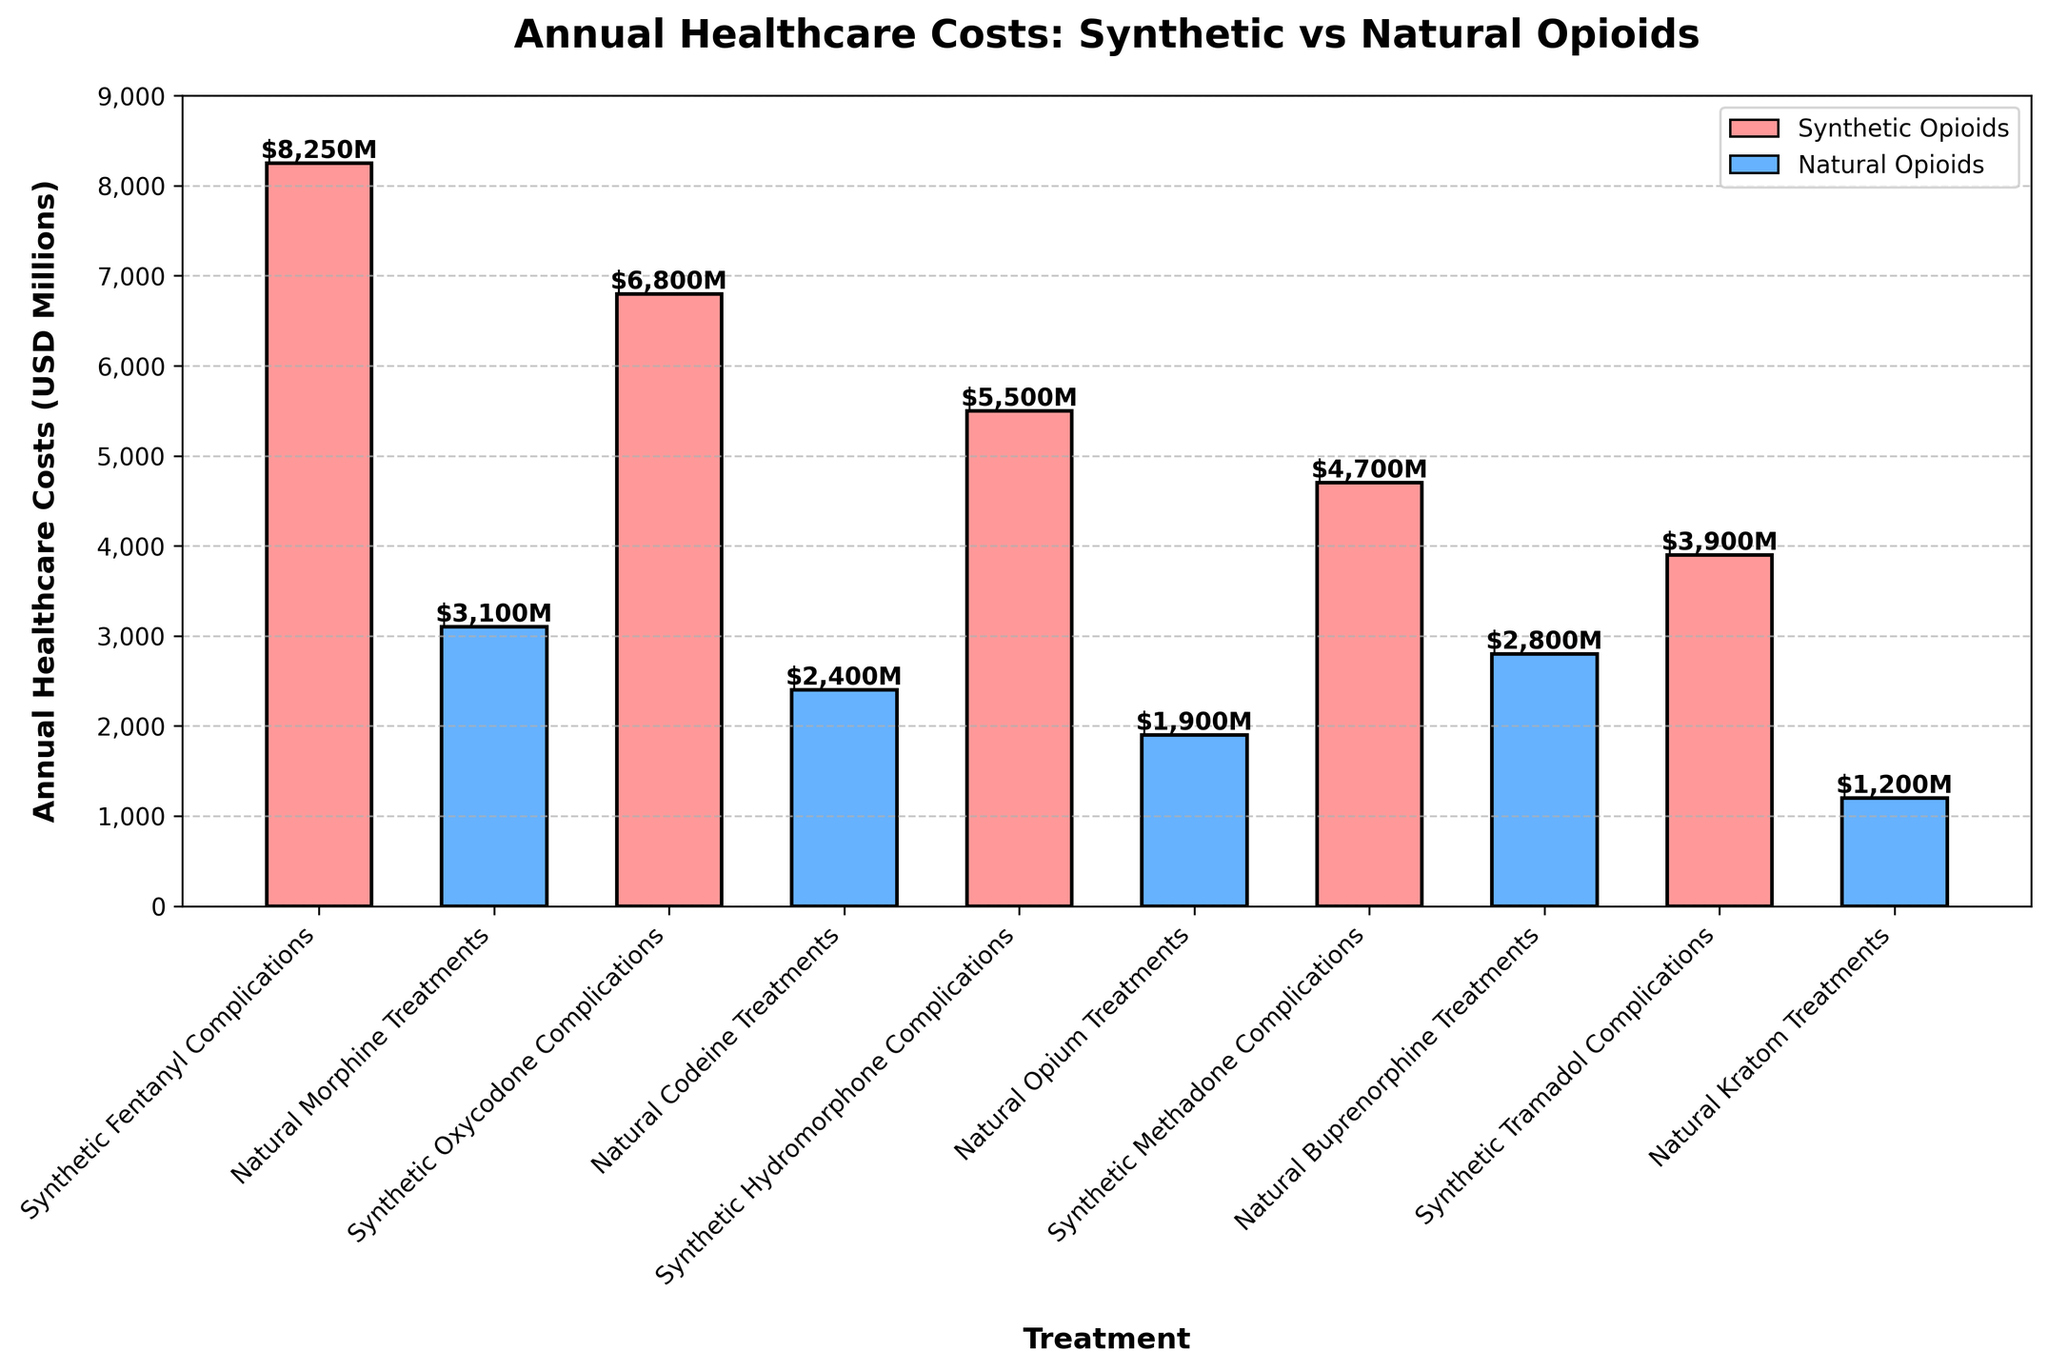Which treatment has the highest annual healthcare cost? The treatment with the highest annual healthcare cost will be the tallest bar in the bar chart. This bar represents synthetic fentanyl complications with a cost of $8,250 million.
Answer: Synthetic fentanyl complications Which treatment has the lowest annual healthcare cost? The treatment with the lowest annual healthcare cost will be the shortest bar in the bar chart. This bar represents natural kratom treatments with a cost of $1,200 million.
Answer: Natural kratom treatments What is the total annual healthcare cost for all synthetic opioid-related complications? Sum the annual healthcare costs of all synthetic opioid-related complications: $8,250M (fentanyl) + $6,800M (oxycodone) + $5,500M (hydromorphone) + $4,700M (methadone) + $3,900M (tramadol) = $29,150 million.
Answer: $29,150 million What is the average annual healthcare cost for natural opioid treatments? Calculate the average by summing the annual healthcare costs of natural opioid treatments and dividing by the number of treatments: ($3,100M + $2,400M + $1,900M + $2,800M + $1,200M) / 5 = $11,400M / 5 = $2,280 million.
Answer: $2,280 million How much higher is the cost of synthetic oxycodone complications compared to natural codeine treatments? Subtract the annual healthcare cost of natural codeine treatments from the cost of synthetic oxycodone complications: $6,800M - $2,400M = $4,400 million.
Answer: $4,400 million Which has a greater annual healthcare cost: synthetic methadone complications or natural buprenorphine treatments? Compare the heights of the bars for synthetic methadone complications ($4,700M) and natural buprenorphine treatments ($2,800M). Synthetic methadone complications have a greater cost.
Answer: Synthetic methadone complications How do the total annual healthcare costs for natural opium treatments and natural buprenorphine treatments compare? Add the annual healthcare costs of natural opium treatments and natural buprenorphine treatments: $1,900M (opium) + $2,800M (buprenorphine) = $4,700 million. It's equal to synthetic methadone complications.
Answer: $4,700 million, equal to synthetic methadone complications What is the difference in annual healthcare costs between the highest and lowest treatments? Subtract the annual healthcare cost of the lowest-cost treatment (natural kratom treatments, $1,200M) from the highest-cost treatment (synthetic fentanyl complications, $8,250M): $8,250M - $1,200M = $7,050 million.
Answer: $7,050 million What's the combined cost of synthetic hydromorphone complications and natural morphine treatments? Sum the annual healthcare costs of synthetic hydromorphone complications and natural morphine treatments: $5,500M (hydromorphone) + $3,100M (morphine) = $8,600 million.
Answer: $8,600 million Are the costs of natural opioid treatments generally higher or lower than those of synthetic opioid complications? Compare the general height of bars corresponding to synthetic opioid complications and natural opioid treatments. The synthetic opioid complication bars (like fentanyl, oxycodone) are consistently taller than the natural opioid treatment bars (like morphine, codeine).
Answer: Lower 